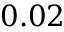<formula> <loc_0><loc_0><loc_500><loc_500>0 . 0 2</formula> 